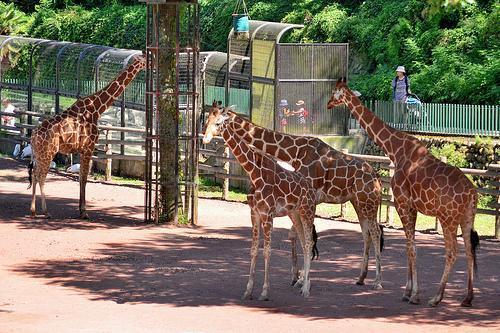How many giraffes are to the left of the caged tree?
Give a very brief answer. 1. 